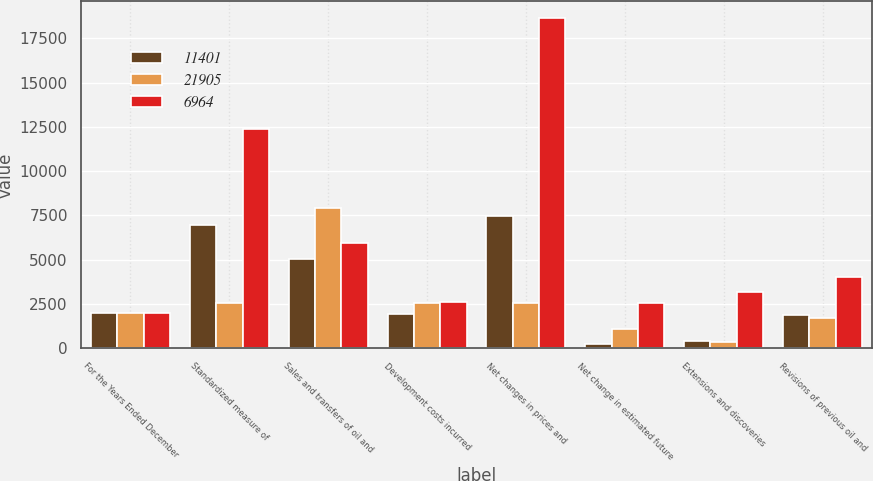<chart> <loc_0><loc_0><loc_500><loc_500><stacked_bar_chart><ecel><fcel>For the Years Ended December<fcel>Standardized measure of<fcel>Sales and transfers of oil and<fcel>Development costs incurred<fcel>Net changes in prices and<fcel>Net change in estimated future<fcel>Extensions and discoveries<fcel>Revisions of previous oil and<nl><fcel>11401<fcel>2009<fcel>6964<fcel>5030<fcel>1927<fcel>7484<fcel>227<fcel>426<fcel>1855<nl><fcel>21905<fcel>2008<fcel>2538.5<fcel>7934<fcel>2523<fcel>2538.5<fcel>1056<fcel>334<fcel>1730<nl><fcel>6964<fcel>2007<fcel>12361<fcel>5917<fcel>2605<fcel>18646<fcel>2554<fcel>3173<fcel>4036<nl></chart> 